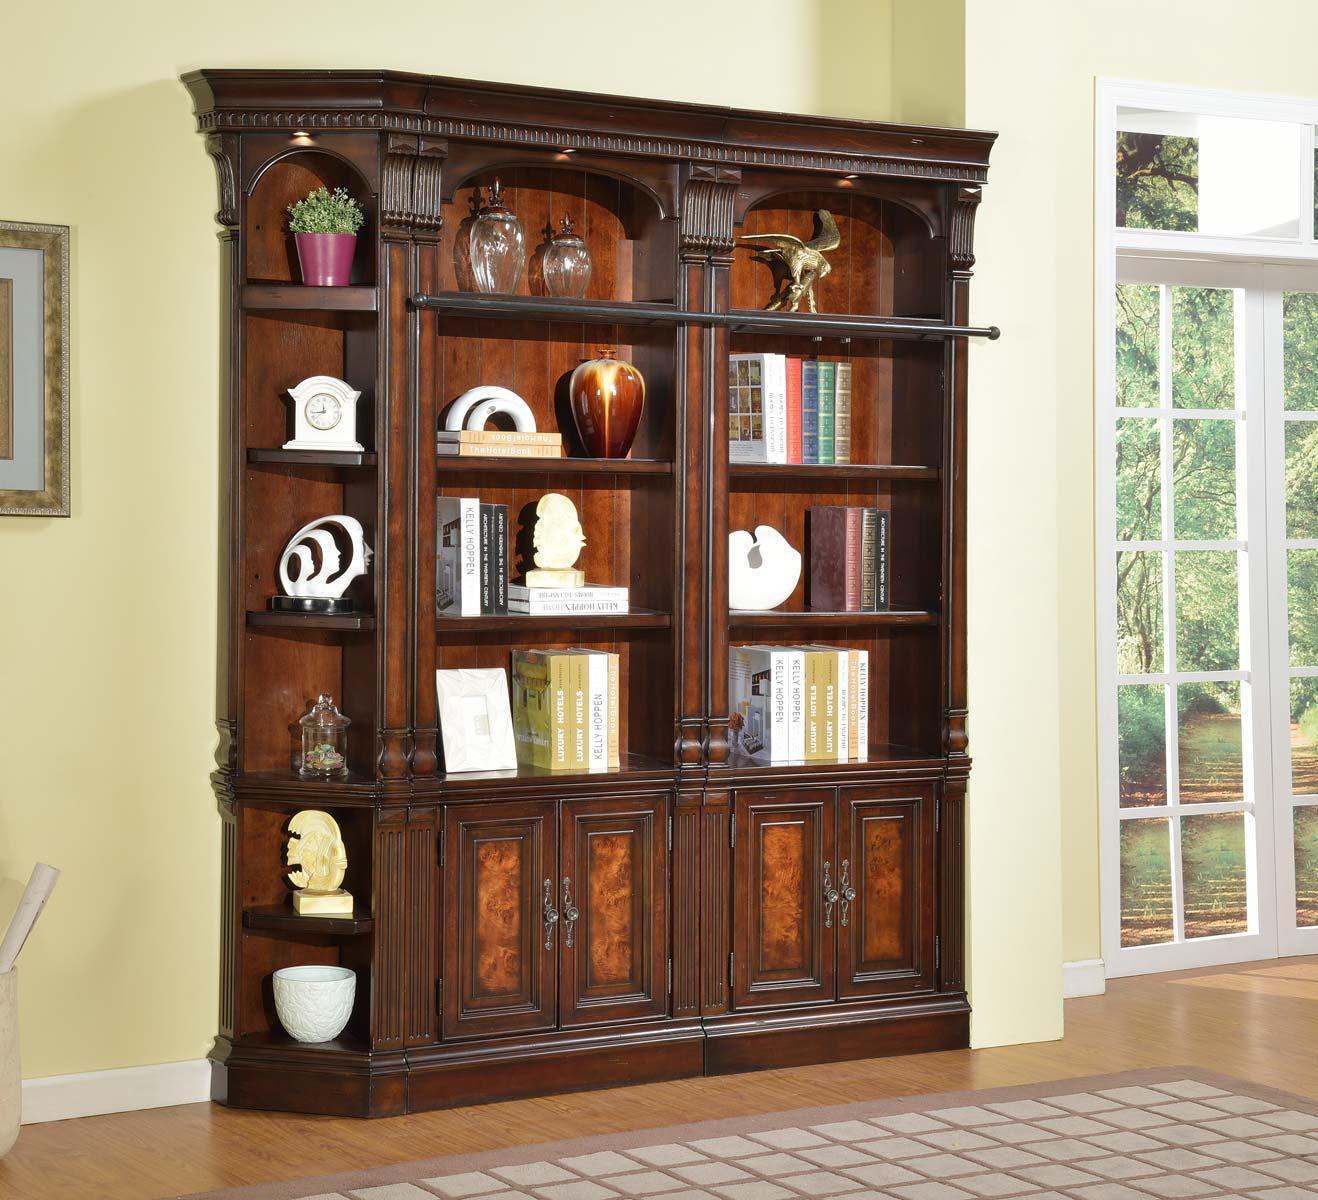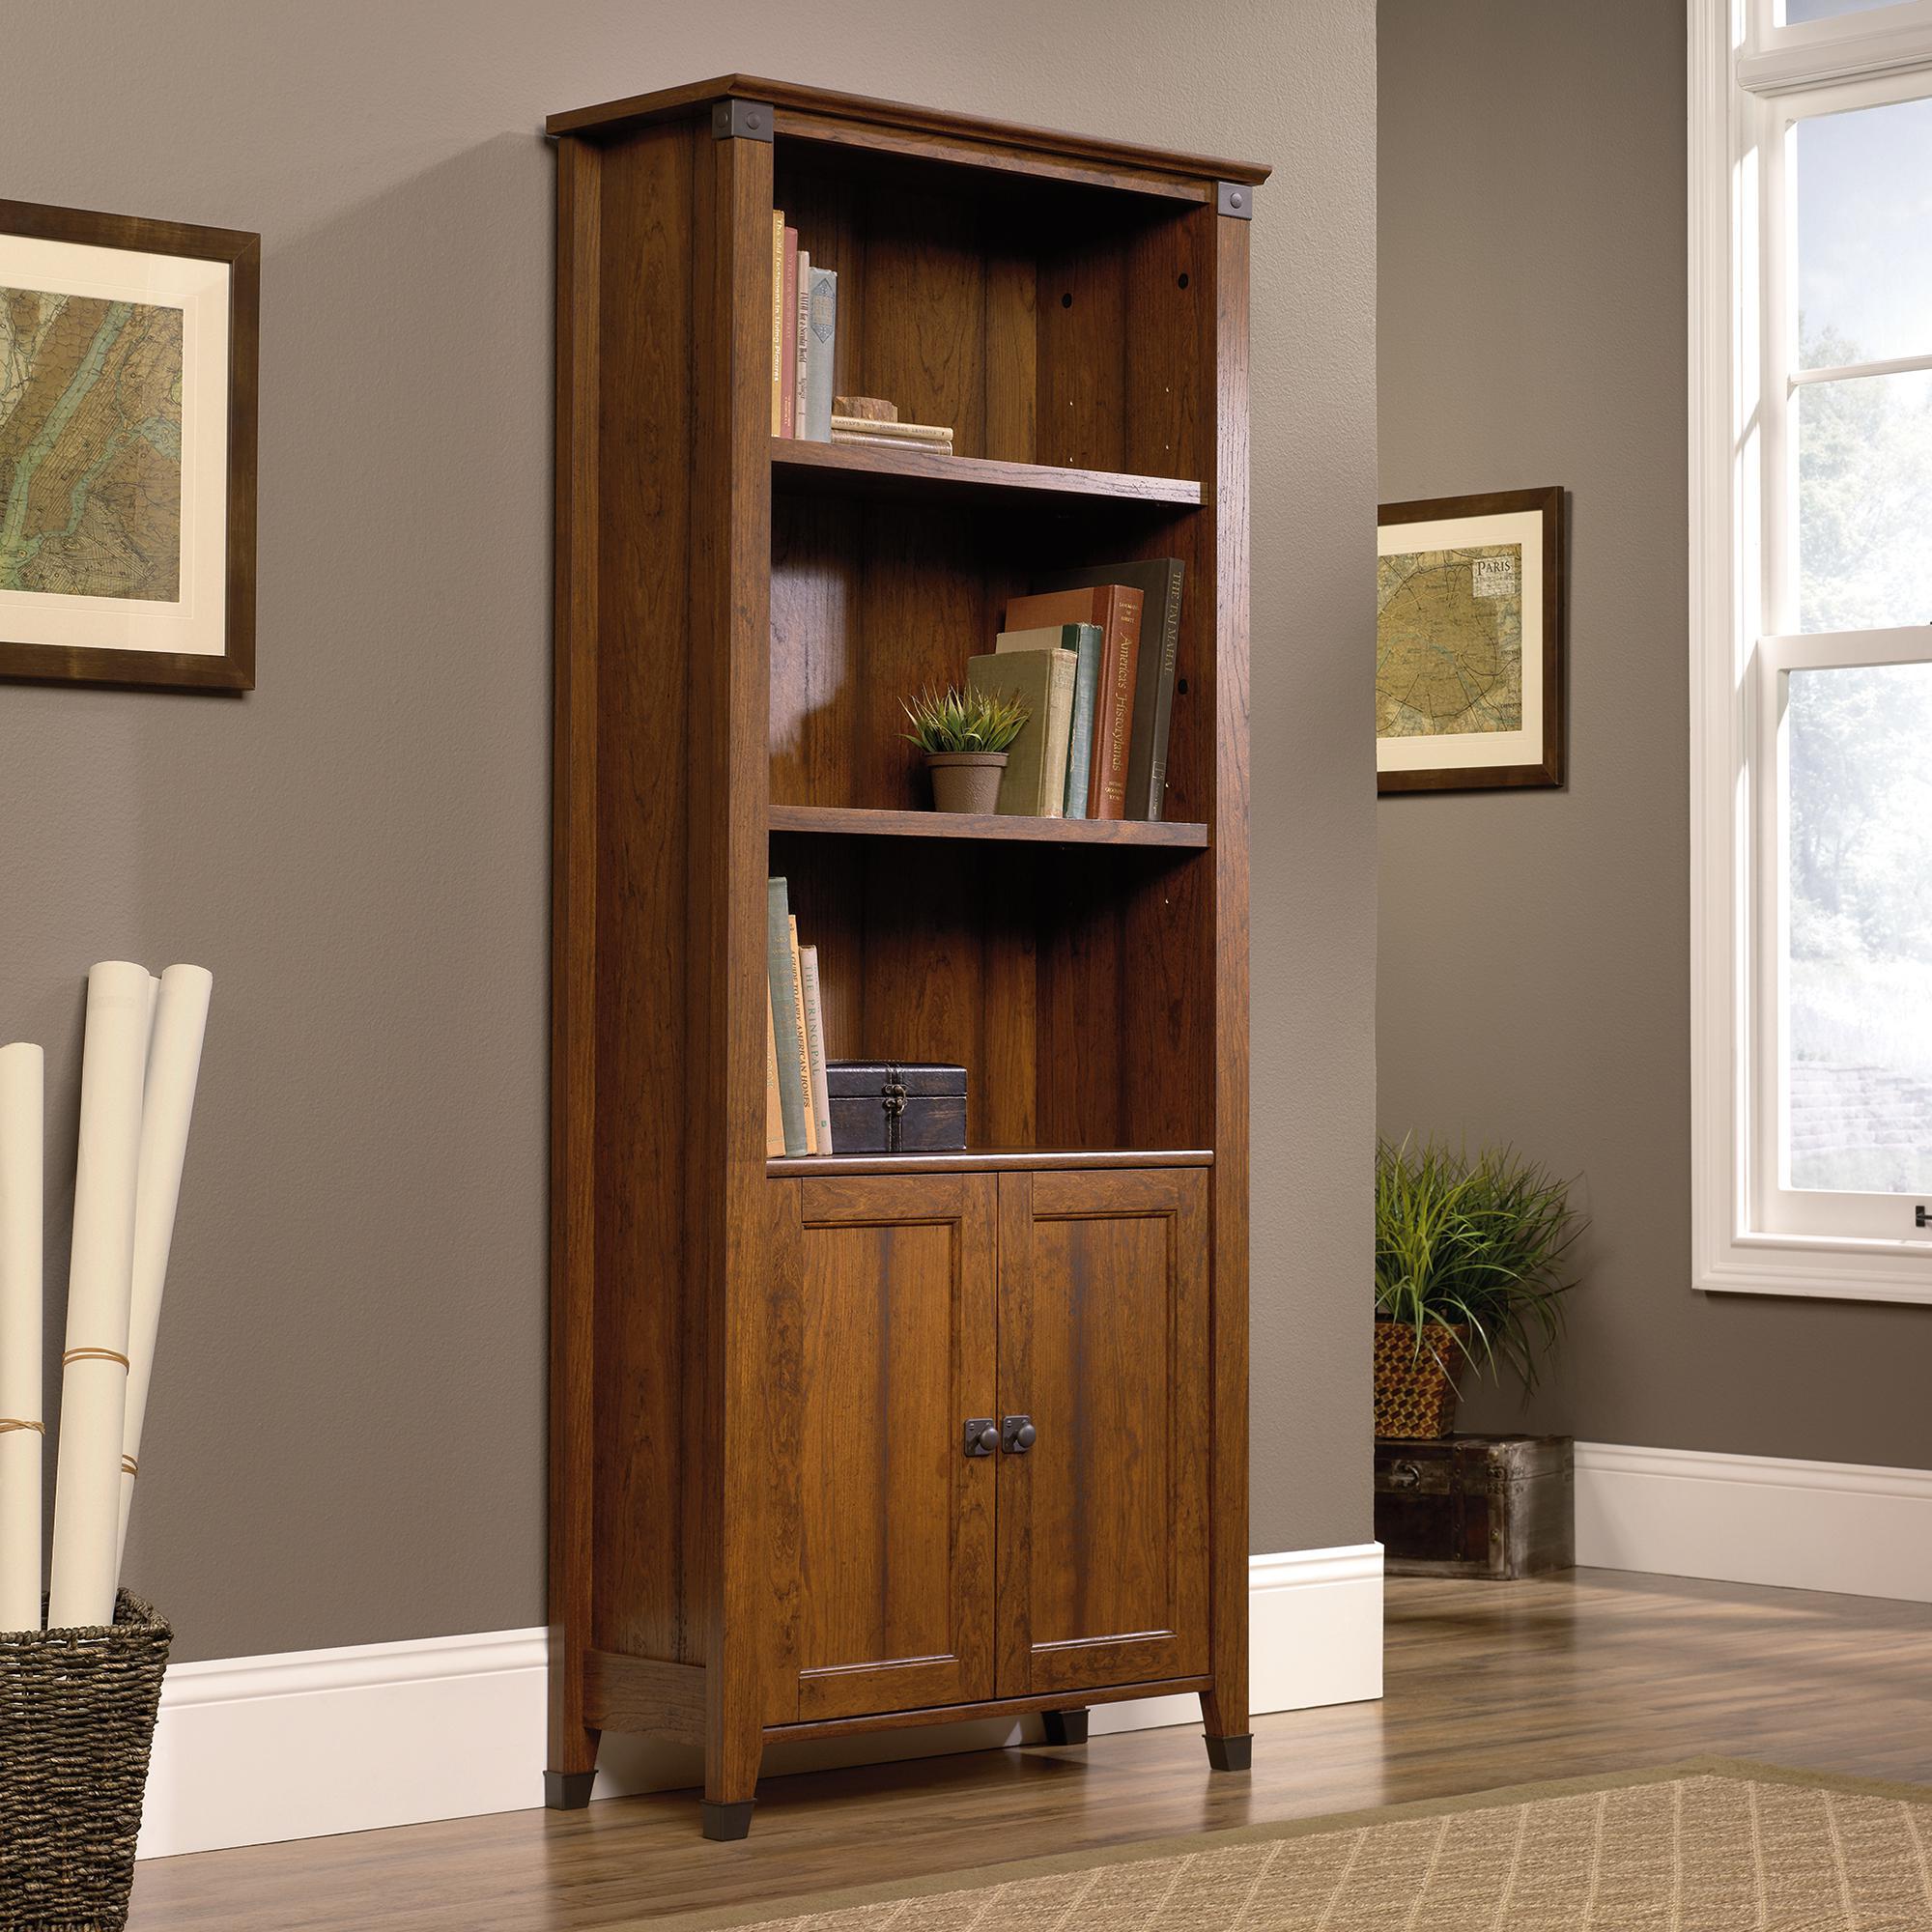The first image is the image on the left, the second image is the image on the right. For the images shown, is this caption "In at least one image, there is a window with a curtain to the left of a bookcase." true? Answer yes or no. No. 